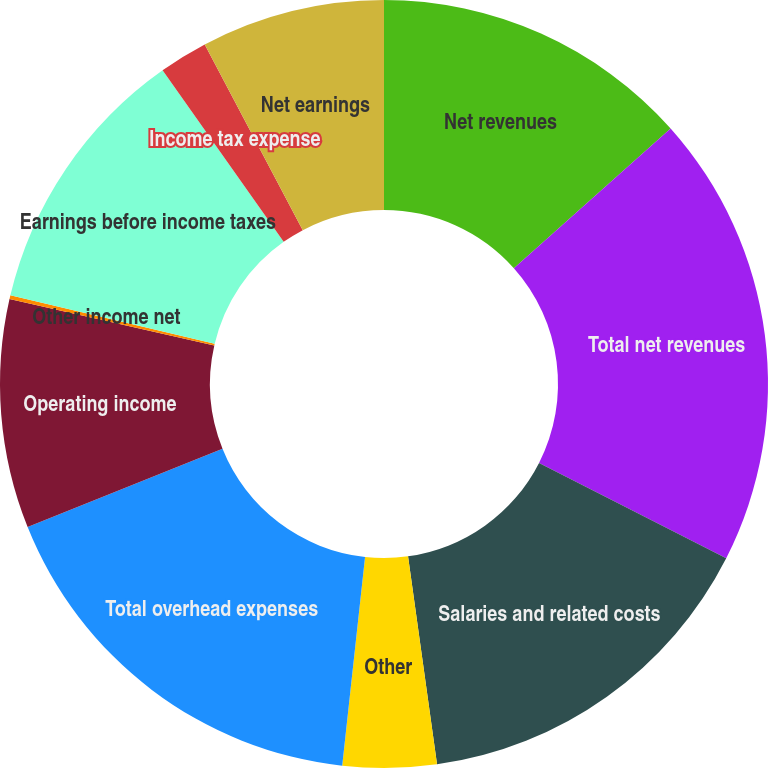Convert chart. <chart><loc_0><loc_0><loc_500><loc_500><pie_chart><fcel>Net revenues<fcel>Total net revenues<fcel>Salaries and related costs<fcel>Other<fcel>Total overhead expenses<fcel>Operating income<fcel>Other income net<fcel>Earnings before income taxes<fcel>Income tax expense<fcel>Net earnings<nl><fcel>13.41%<fcel>19.08%<fcel>15.3%<fcel>3.94%<fcel>17.19%<fcel>9.62%<fcel>0.16%<fcel>11.51%<fcel>2.05%<fcel>7.73%<nl></chart> 